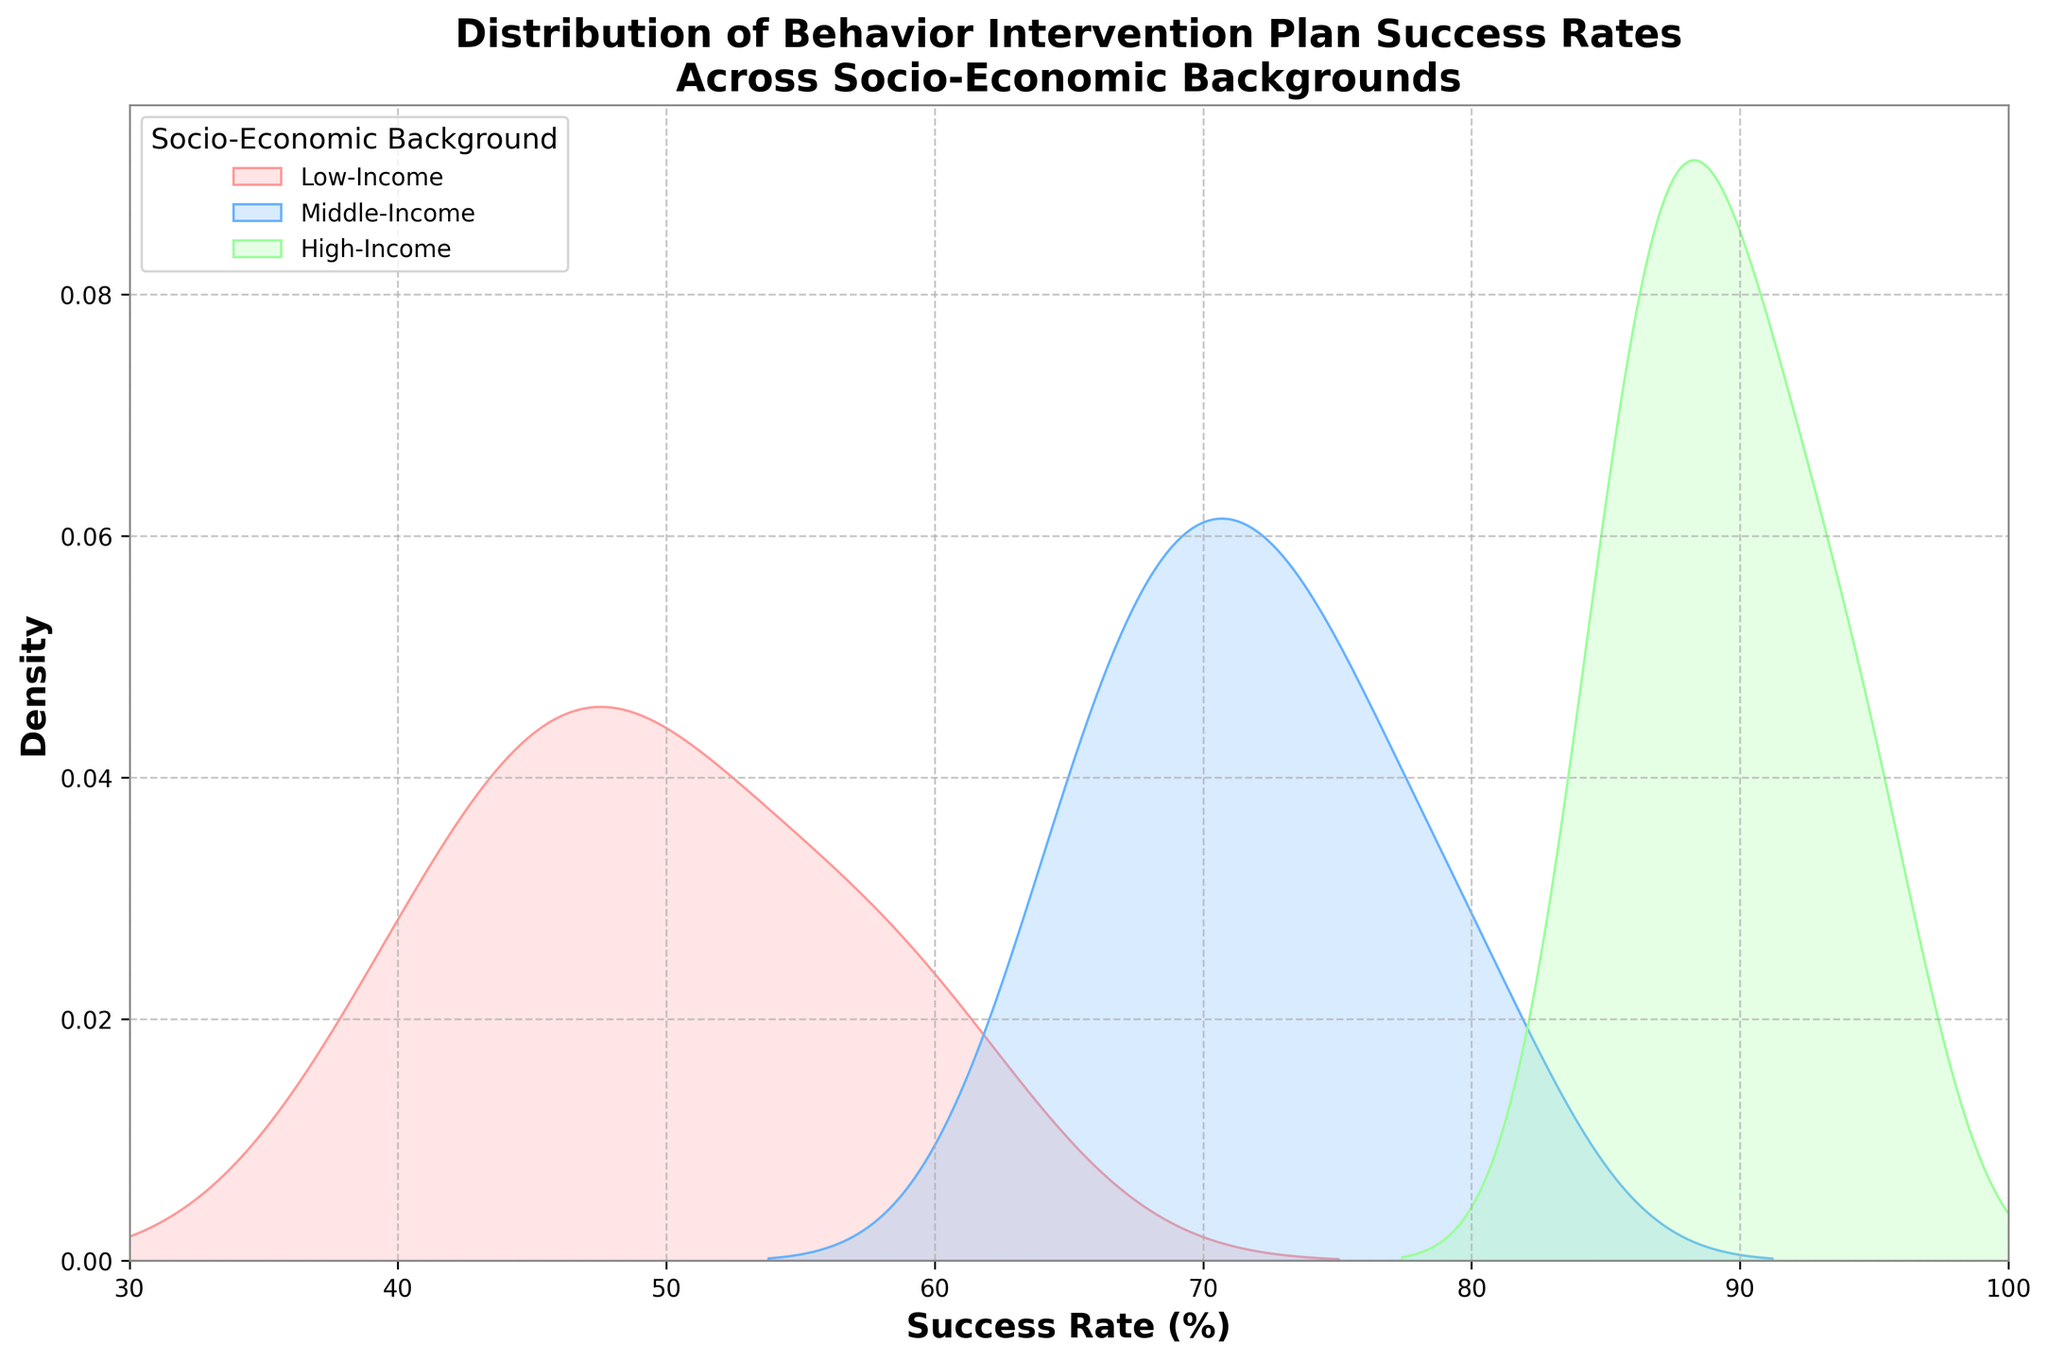What is the title of the figure? The title can be found at the top of the figure. It provides an overall description of what the figure is showing.
Answer: Distribution of Behavior Intervention Plan Success Rates Across Socio-Economic Backgrounds What does the x-axis represent in this figure? The label of the x-axis is mentioned directly under the x-axis. It indicates the variable being measured and displayed along this axis.
Answer: Success Rate (%) Which socio-economic group shows a higher peak in success rates around the 70-80% range? To determine this, we need to look at the region of the plot around 70-80% on the x-axis and see which group has the highest density (peak) there.
Answer: Middle-Income Which socio-economic background has the most spread out success rates? To answer this, examine which group has the widest distribution along the x-axis, indicating higher variance in success rates.
Answer: Low-Income What can you deduce about the high-income group's success rates? From the plot, we need to observe the range and peak of the high-income group's distribution to understand their success rate trends.
Answer: Mostly between 85% and 95% How does the success rate range of the middle-income group compare to that of the low-income group? Compare the x-axis range for each group mentioned to identify the spread of success rates.
Answer: Middle-Income ranges from 65% to 80%; Low-Income ranges from 40% to 60% Among the three groups, which one has a comparatively tighter cluster of success rates? Identify the group whose distribution has less width and a more concentrated peak, indicating less variance in success rates.
Answer: High-Income Is there a socio-economic background that predominantly has its success rates below 50%? Determine if any of the distributions have significant density below the 50% mark on the x-axis.
Answer: Low-Income Which socio-economic group has the highest success rate density around 90%? Identify the group with the highest peak near the 90% mark on the x-axis.
Answer: High-Income Are there any overlaps between the success rates of the different socio-economic backgrounds? Look for regions on the x-axis where the distributions of different groups intersect or overlap.
Answer: Yes, especially around 60%-80% 